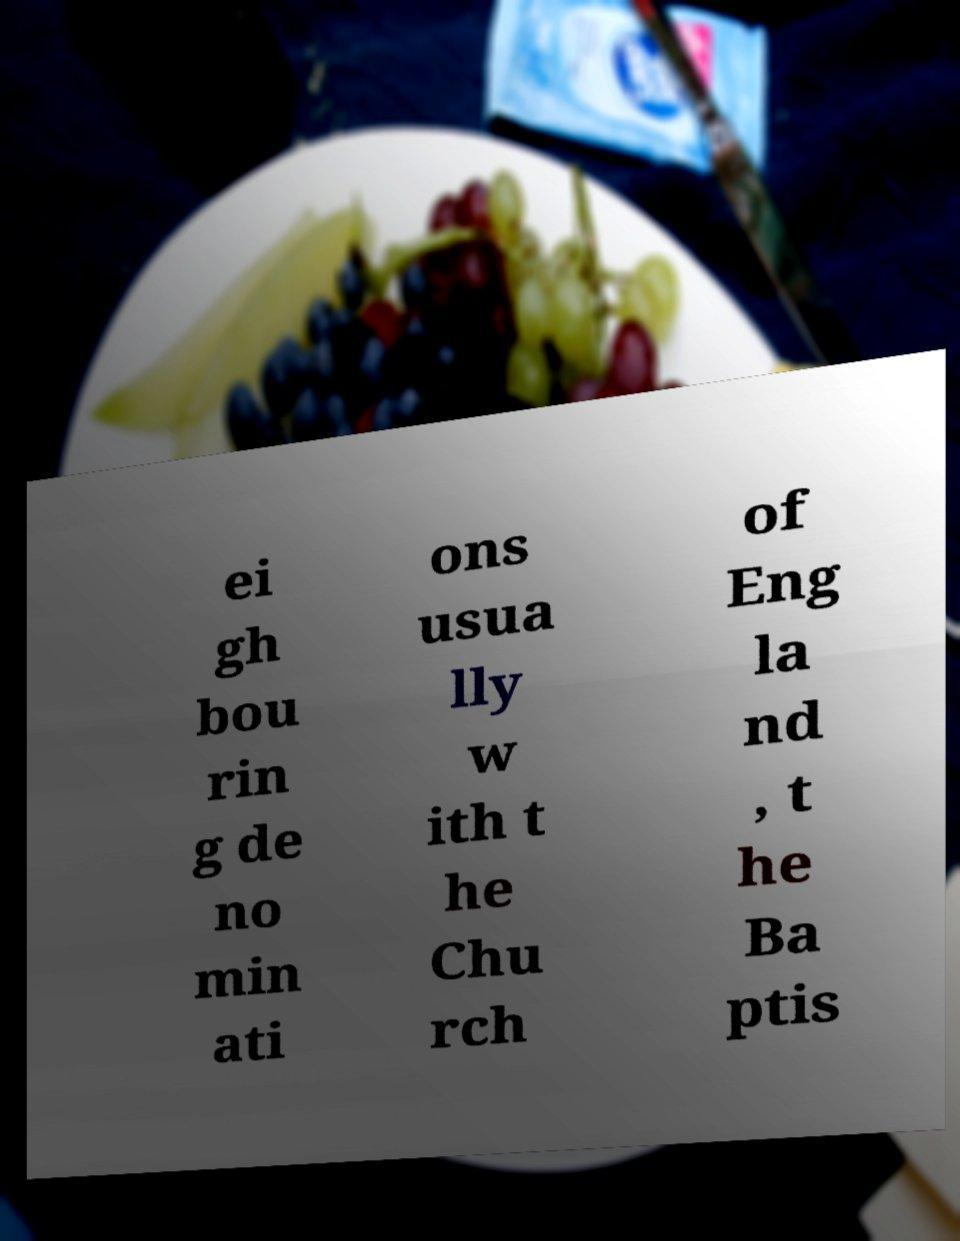I need the written content from this picture converted into text. Can you do that? ei gh bou rin g de no min ati ons usua lly w ith t he Chu rch of Eng la nd , t he Ba ptis 